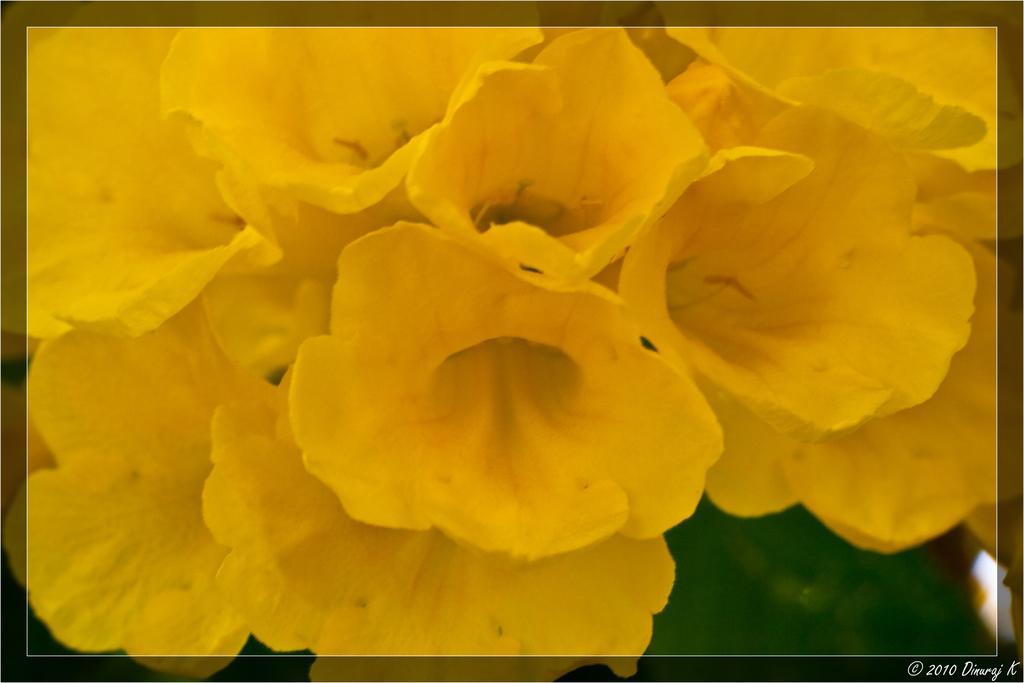Can you describe this image briefly? In this image there are yellow flowers, in the bottom right there is a text. 